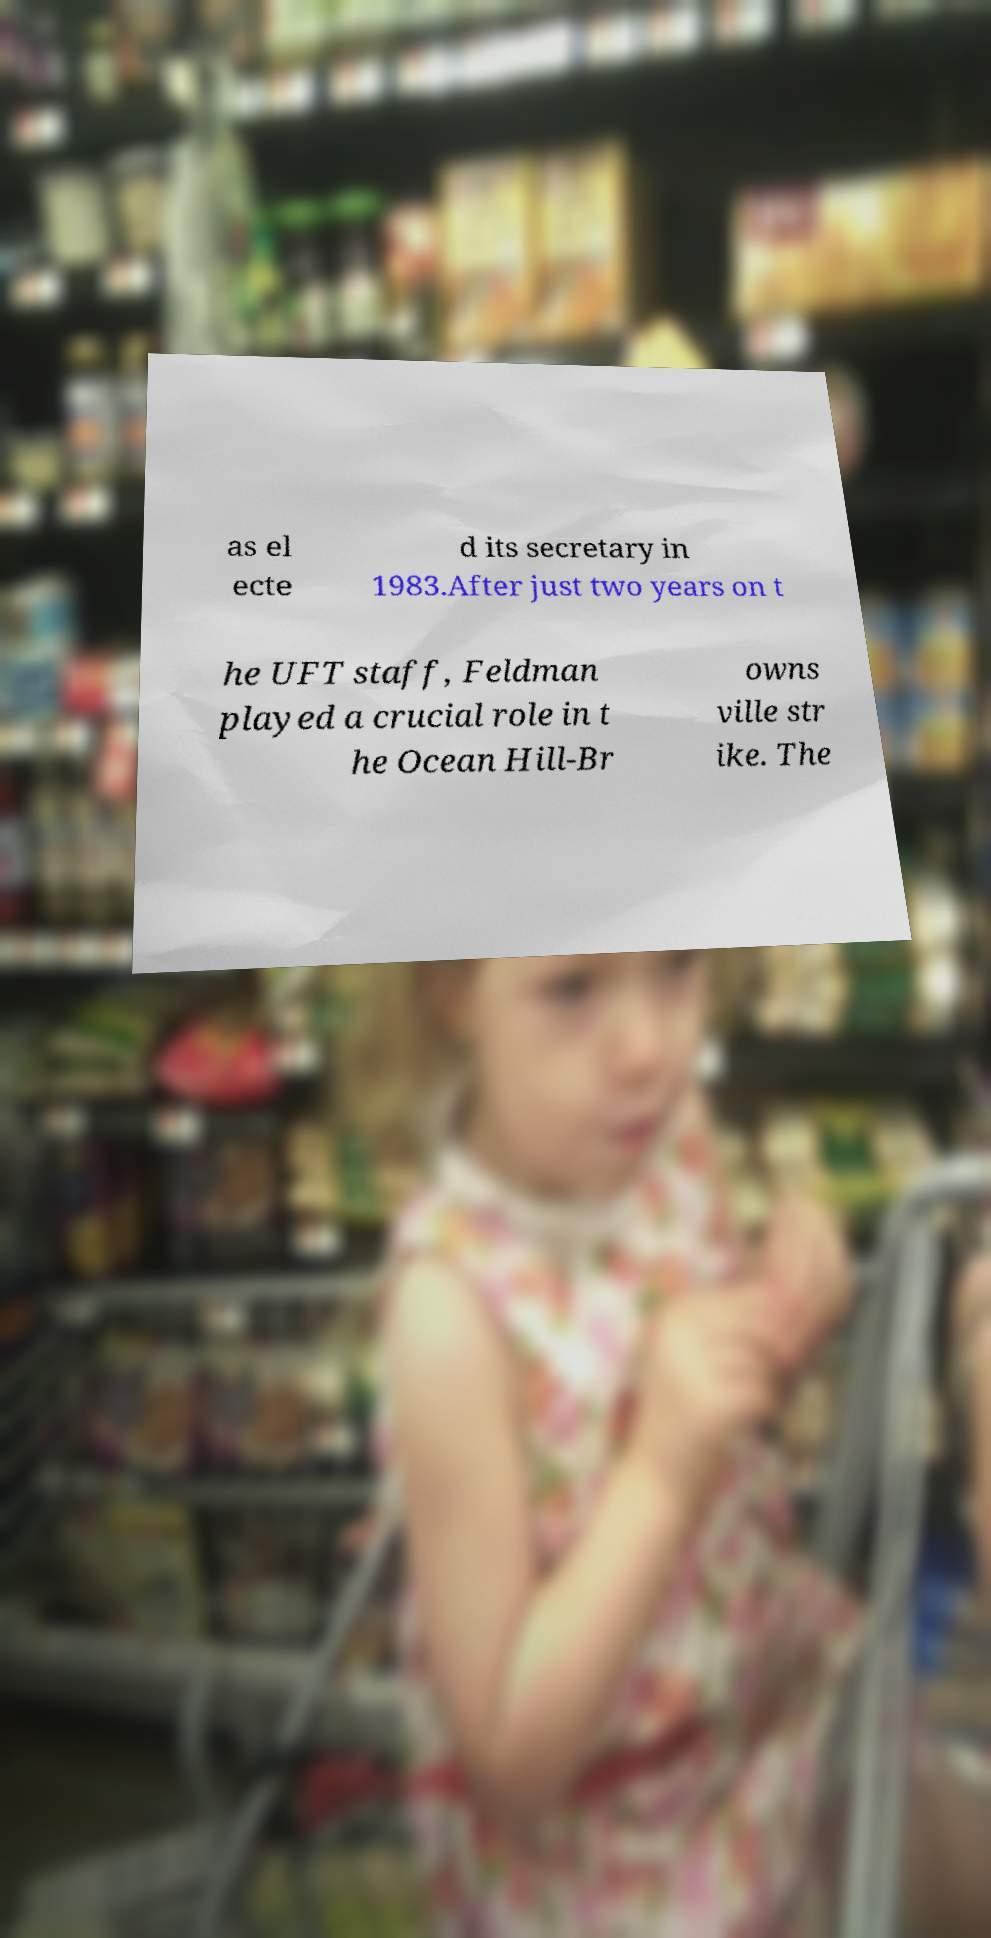I need the written content from this picture converted into text. Can you do that? as el ecte d its secretary in 1983.After just two years on t he UFT staff, Feldman played a crucial role in t he Ocean Hill-Br owns ville str ike. The 